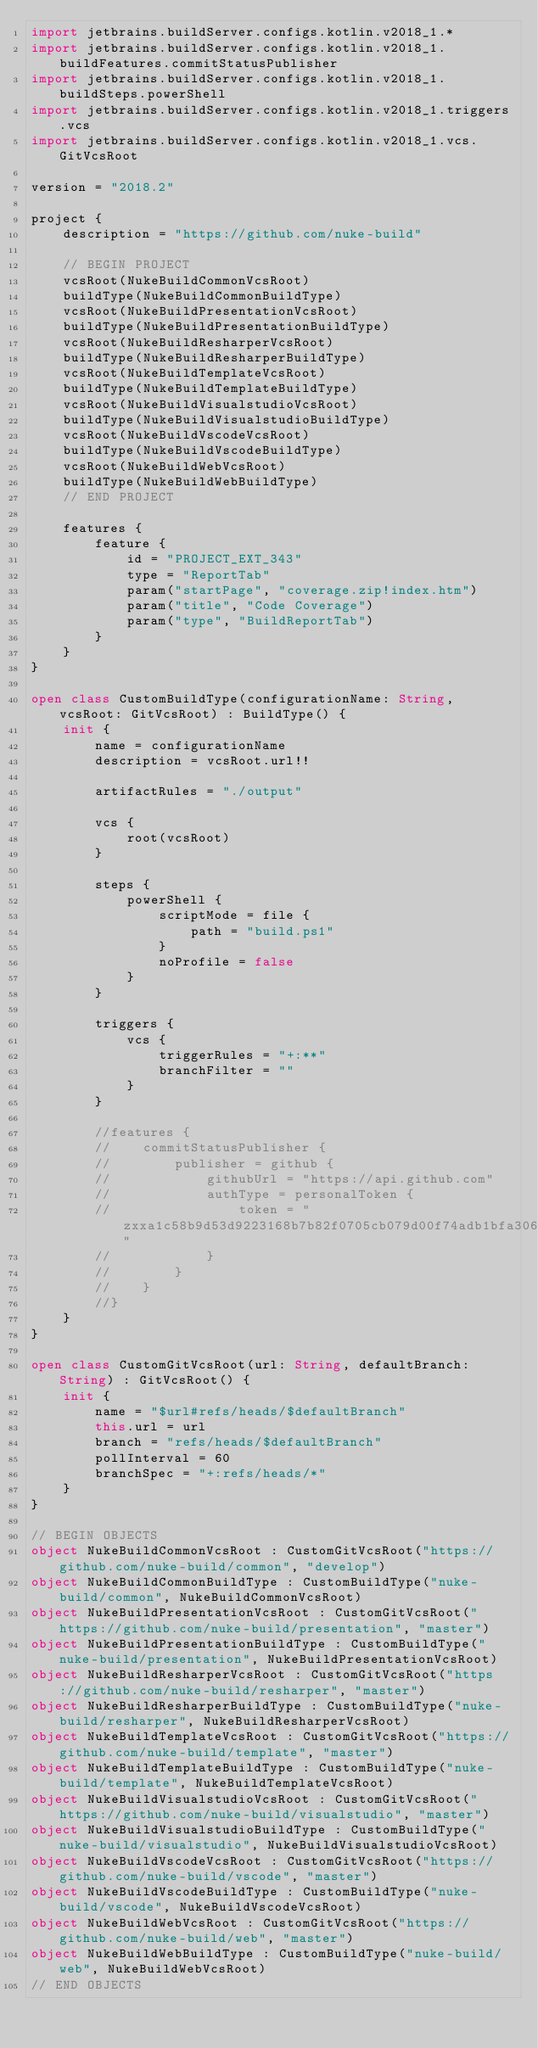<code> <loc_0><loc_0><loc_500><loc_500><_Kotlin_>import jetbrains.buildServer.configs.kotlin.v2018_1.*
import jetbrains.buildServer.configs.kotlin.v2018_1.buildFeatures.commitStatusPublisher
import jetbrains.buildServer.configs.kotlin.v2018_1.buildSteps.powerShell
import jetbrains.buildServer.configs.kotlin.v2018_1.triggers.vcs
import jetbrains.buildServer.configs.kotlin.v2018_1.vcs.GitVcsRoot

version = "2018.2"

project {
    description = "https://github.com/nuke-build"

    // BEGIN PROJECT
    vcsRoot(NukeBuildCommonVcsRoot)
    buildType(NukeBuildCommonBuildType)
    vcsRoot(NukeBuildPresentationVcsRoot)
    buildType(NukeBuildPresentationBuildType)
    vcsRoot(NukeBuildResharperVcsRoot)
    buildType(NukeBuildResharperBuildType)
    vcsRoot(NukeBuildTemplateVcsRoot)
    buildType(NukeBuildTemplateBuildType)
    vcsRoot(NukeBuildVisualstudioVcsRoot)
    buildType(NukeBuildVisualstudioBuildType)
    vcsRoot(NukeBuildVscodeVcsRoot)
    buildType(NukeBuildVscodeBuildType)
    vcsRoot(NukeBuildWebVcsRoot)
    buildType(NukeBuildWebBuildType)
    // END PROJECT

    features {
        feature {
            id = "PROJECT_EXT_343"
            type = "ReportTab"
            param("startPage", "coverage.zip!index.htm")
            param("title", "Code Coverage")
            param("type", "BuildReportTab")
        }
    }
}

open class CustomBuildType(configurationName: String, vcsRoot: GitVcsRoot) : BuildType() {
    init {
        name = configurationName
        description = vcsRoot.url!!

        artifactRules = "./output"

        vcs {
            root(vcsRoot)
        }

        steps {
            powerShell {
                scriptMode = file {
                    path = "build.ps1"
                }
                noProfile = false
            }
        }

        triggers {
            vcs {
                triggerRules = "+:**"
                branchFilter = ""
            }
        }

        //features {
        //    commitStatusPublisher {
        //        publisher = github {
        //            githubUrl = "https://api.github.com"
        //            authType = personalToken {
        //                token = "zxxa1c58b9d53d9223168b7b82f0705cb079d00f74adb1bfa306e19338b11d18c5570fb8c0d87e1be54775d03cbe80d301b"
        //            }
        //        }
        //    }
        //}
    }
}

open class CustomGitVcsRoot(url: String, defaultBranch: String) : GitVcsRoot() {
    init {
        name = "$url#refs/heads/$defaultBranch"
        this.url = url
        branch = "refs/heads/$defaultBranch"
        pollInterval = 60
        branchSpec = "+:refs/heads/*"
    }
}

// BEGIN OBJECTS
object NukeBuildCommonVcsRoot : CustomGitVcsRoot("https://github.com/nuke-build/common", "develop")
object NukeBuildCommonBuildType : CustomBuildType("nuke-build/common", NukeBuildCommonVcsRoot)
object NukeBuildPresentationVcsRoot : CustomGitVcsRoot("https://github.com/nuke-build/presentation", "master")
object NukeBuildPresentationBuildType : CustomBuildType("nuke-build/presentation", NukeBuildPresentationVcsRoot)
object NukeBuildResharperVcsRoot : CustomGitVcsRoot("https://github.com/nuke-build/resharper", "master")
object NukeBuildResharperBuildType : CustomBuildType("nuke-build/resharper", NukeBuildResharperVcsRoot)
object NukeBuildTemplateVcsRoot : CustomGitVcsRoot("https://github.com/nuke-build/template", "master")
object NukeBuildTemplateBuildType : CustomBuildType("nuke-build/template", NukeBuildTemplateVcsRoot)
object NukeBuildVisualstudioVcsRoot : CustomGitVcsRoot("https://github.com/nuke-build/visualstudio", "master")
object NukeBuildVisualstudioBuildType : CustomBuildType("nuke-build/visualstudio", NukeBuildVisualstudioVcsRoot)
object NukeBuildVscodeVcsRoot : CustomGitVcsRoot("https://github.com/nuke-build/vscode", "master")
object NukeBuildVscodeBuildType : CustomBuildType("nuke-build/vscode", NukeBuildVscodeVcsRoot)
object NukeBuildWebVcsRoot : CustomGitVcsRoot("https://github.com/nuke-build/web", "master")
object NukeBuildWebBuildType : CustomBuildType("nuke-build/web", NukeBuildWebVcsRoot)
// END OBJECTS
</code> 